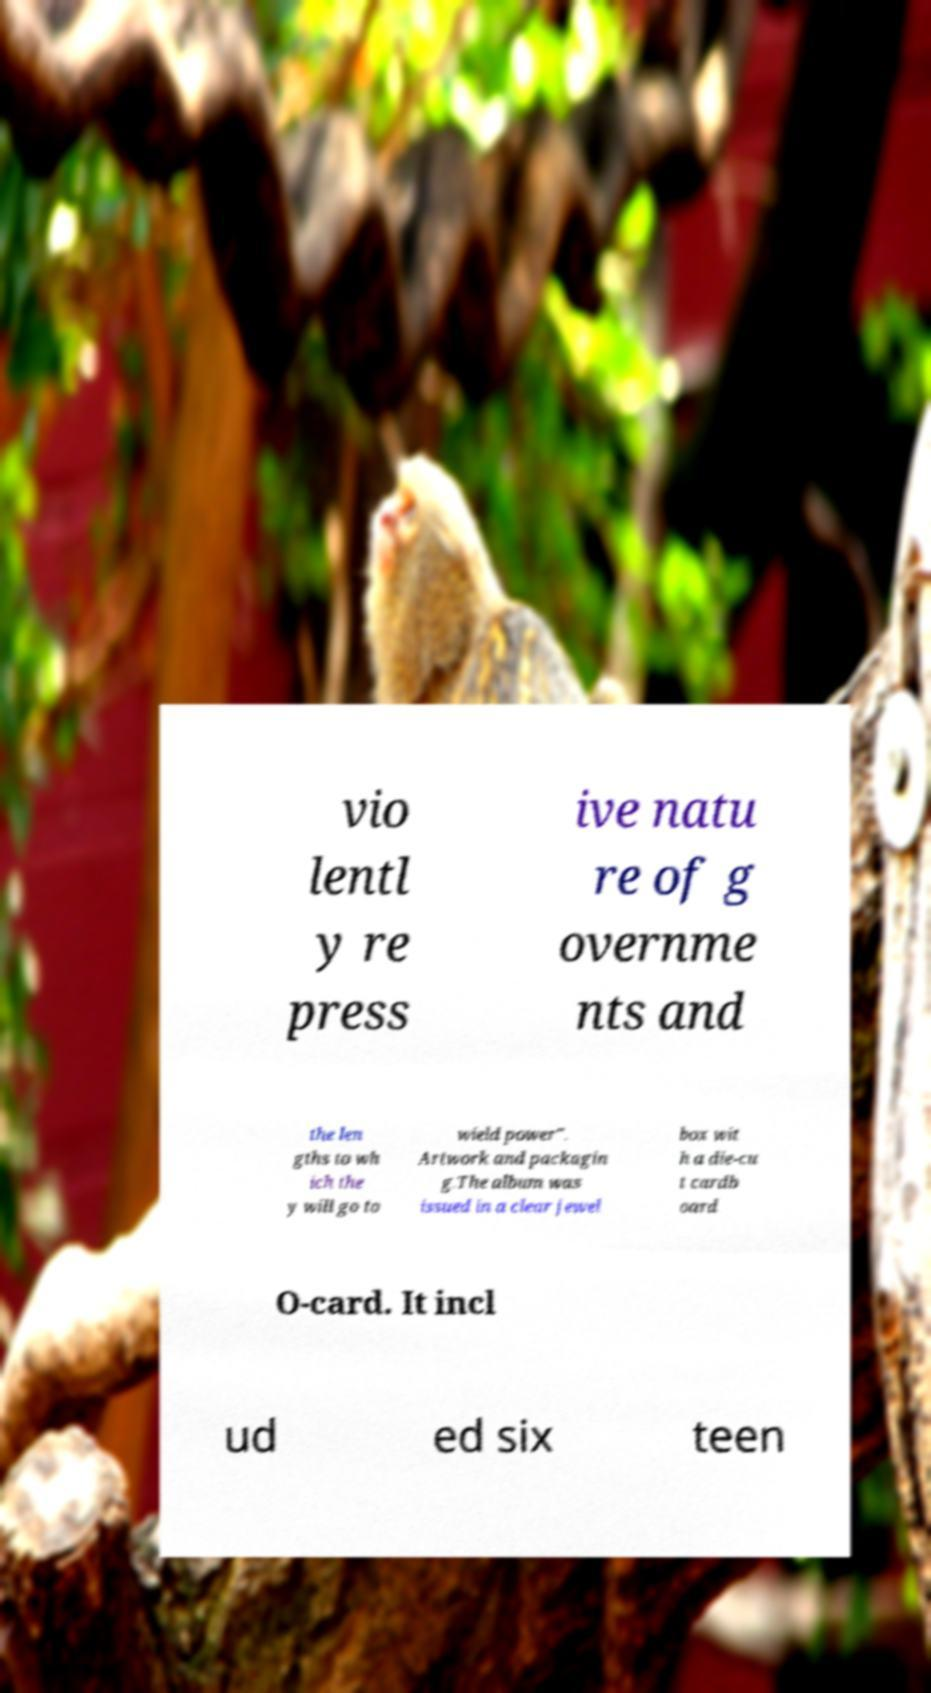Can you accurately transcribe the text from the provided image for me? vio lentl y re press ive natu re of g overnme nts and the len gths to wh ich the y will go to wield power". Artwork and packagin g.The album was issued in a clear jewel box wit h a die-cu t cardb oard O-card. It incl ud ed six teen 